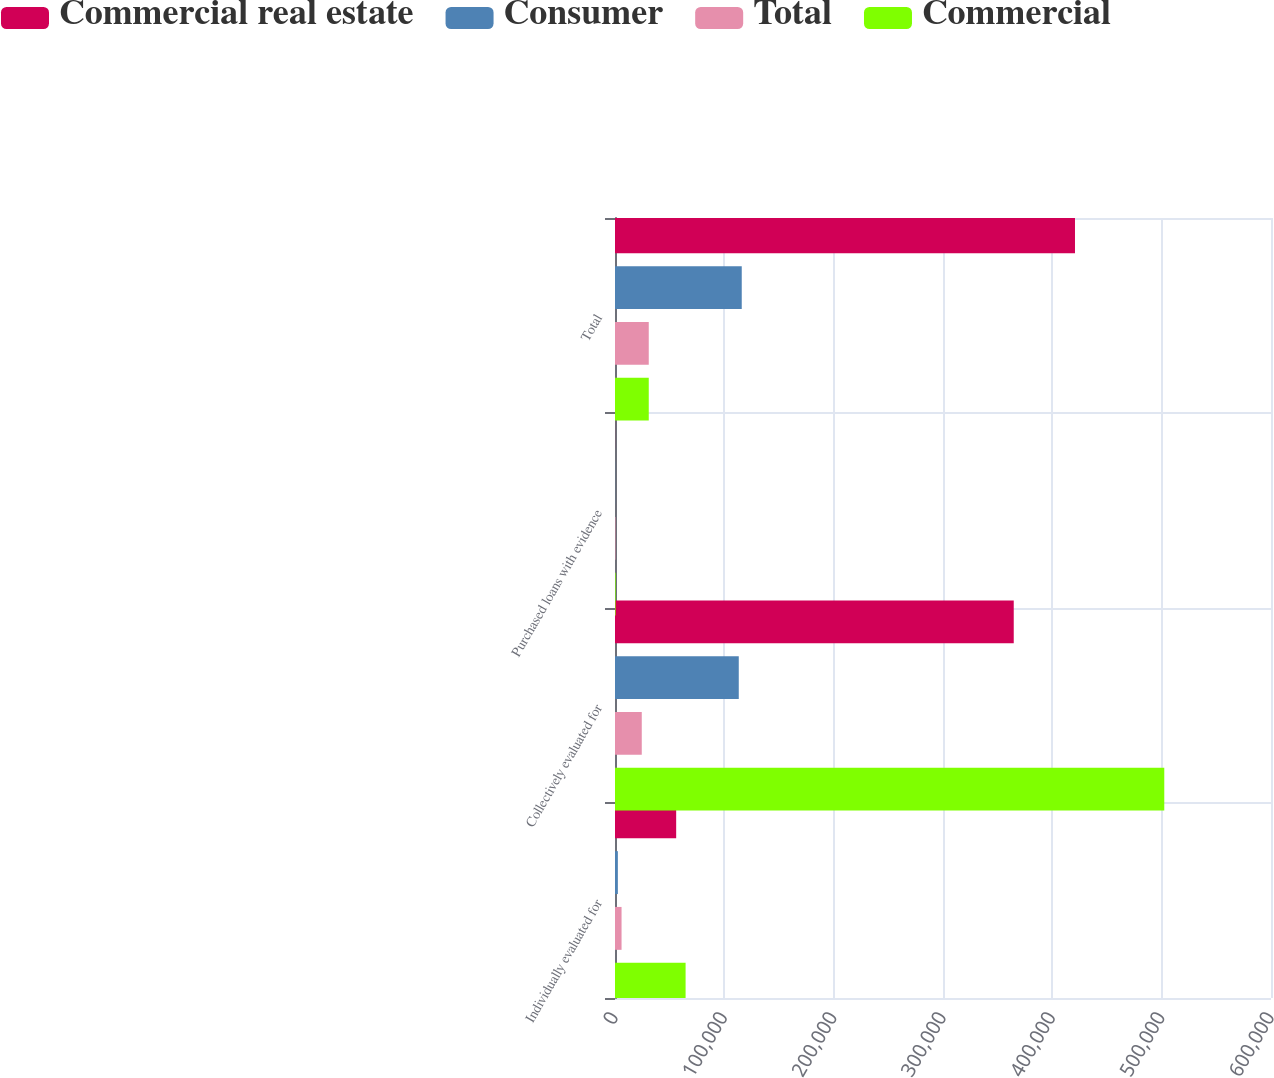Convert chart to OTSL. <chart><loc_0><loc_0><loc_500><loc_500><stacked_bar_chart><ecel><fcel>Individually evaluated for<fcel>Collectively evaluated for<fcel>Purchased loans with evidence<fcel>Total<nl><fcel>Commercial real estate<fcel>55951<fcel>364703<fcel>66<fcel>420720<nl><fcel>Consumer<fcel>2620<fcel>113202<fcel>105<fcel>115927<nl><fcel>Total<fcel>5995<fcel>24483<fcel>397<fcel>30875<nl><fcel>Commercial<fcel>64566<fcel>502388<fcel>568<fcel>30875<nl></chart> 